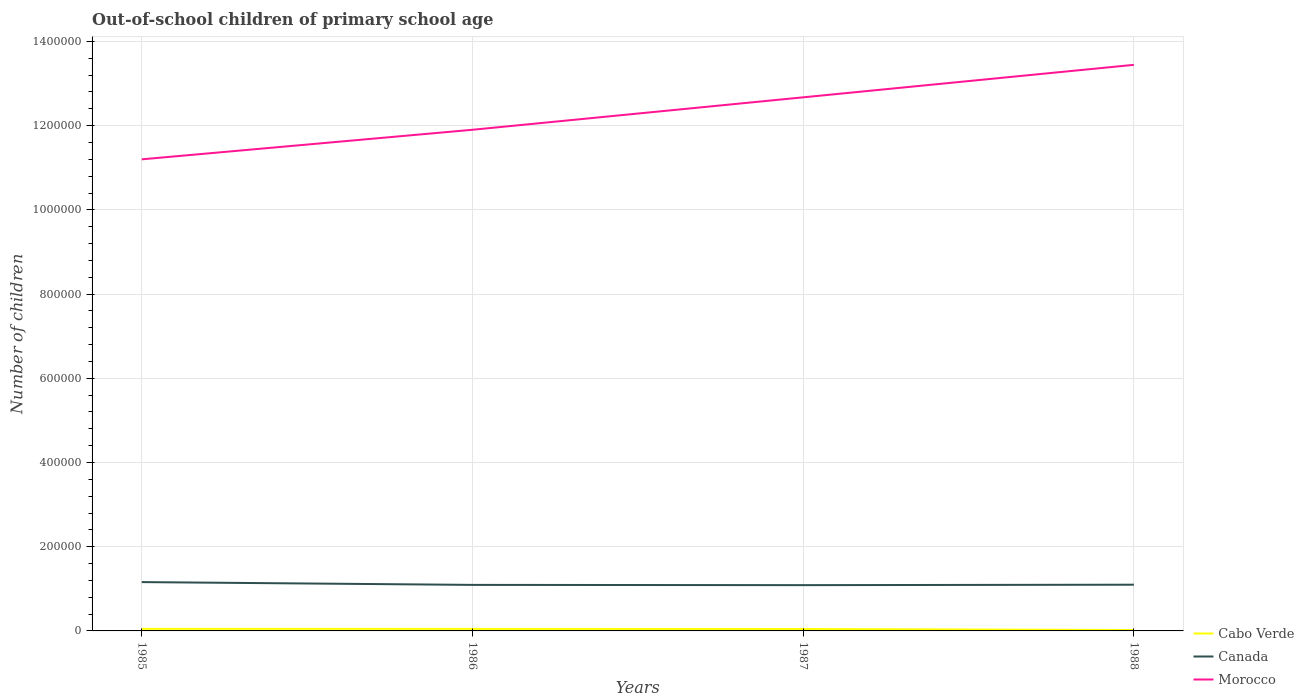Does the line corresponding to Cabo Verde intersect with the line corresponding to Morocco?
Your response must be concise. No. Is the number of lines equal to the number of legend labels?
Make the answer very short. Yes. Across all years, what is the maximum number of out-of-school children in Canada?
Provide a succinct answer. 1.09e+05. What is the total number of out-of-school children in Canada in the graph?
Provide a short and direct response. 7207. What is the difference between the highest and the second highest number of out-of-school children in Morocco?
Provide a succinct answer. 2.24e+05. Does the graph contain grids?
Your answer should be compact. Yes. Where does the legend appear in the graph?
Provide a short and direct response. Bottom right. What is the title of the graph?
Your answer should be very brief. Out-of-school children of primary school age. What is the label or title of the Y-axis?
Provide a succinct answer. Number of children. What is the Number of children of Cabo Verde in 1985?
Ensure brevity in your answer.  4877. What is the Number of children of Canada in 1985?
Keep it short and to the point. 1.16e+05. What is the Number of children in Morocco in 1985?
Provide a succinct answer. 1.12e+06. What is the Number of children in Cabo Verde in 1986?
Keep it short and to the point. 4765. What is the Number of children in Canada in 1986?
Offer a very short reply. 1.09e+05. What is the Number of children of Morocco in 1986?
Make the answer very short. 1.19e+06. What is the Number of children in Cabo Verde in 1987?
Provide a succinct answer. 4602. What is the Number of children in Canada in 1987?
Make the answer very short. 1.09e+05. What is the Number of children of Morocco in 1987?
Your response must be concise. 1.27e+06. What is the Number of children of Cabo Verde in 1988?
Your response must be concise. 2121. What is the Number of children of Canada in 1988?
Make the answer very short. 1.10e+05. What is the Number of children of Morocco in 1988?
Your response must be concise. 1.34e+06. Across all years, what is the maximum Number of children in Cabo Verde?
Make the answer very short. 4877. Across all years, what is the maximum Number of children of Canada?
Provide a short and direct response. 1.16e+05. Across all years, what is the maximum Number of children of Morocco?
Your response must be concise. 1.34e+06. Across all years, what is the minimum Number of children in Cabo Verde?
Your answer should be compact. 2121. Across all years, what is the minimum Number of children of Canada?
Offer a very short reply. 1.09e+05. Across all years, what is the minimum Number of children in Morocco?
Ensure brevity in your answer.  1.12e+06. What is the total Number of children in Cabo Verde in the graph?
Provide a succinct answer. 1.64e+04. What is the total Number of children in Canada in the graph?
Keep it short and to the point. 4.44e+05. What is the total Number of children in Morocco in the graph?
Provide a short and direct response. 4.92e+06. What is the difference between the Number of children in Cabo Verde in 1985 and that in 1986?
Provide a short and direct response. 112. What is the difference between the Number of children of Canada in 1985 and that in 1986?
Offer a very short reply. 6615. What is the difference between the Number of children of Morocco in 1985 and that in 1986?
Provide a short and direct response. -7.02e+04. What is the difference between the Number of children in Cabo Verde in 1985 and that in 1987?
Your response must be concise. 275. What is the difference between the Number of children of Canada in 1985 and that in 1987?
Your answer should be compact. 7207. What is the difference between the Number of children in Morocco in 1985 and that in 1987?
Offer a terse response. -1.47e+05. What is the difference between the Number of children of Cabo Verde in 1985 and that in 1988?
Keep it short and to the point. 2756. What is the difference between the Number of children in Canada in 1985 and that in 1988?
Your response must be concise. 6168. What is the difference between the Number of children in Morocco in 1985 and that in 1988?
Give a very brief answer. -2.24e+05. What is the difference between the Number of children of Cabo Verde in 1986 and that in 1987?
Offer a terse response. 163. What is the difference between the Number of children of Canada in 1986 and that in 1987?
Your response must be concise. 592. What is the difference between the Number of children of Morocco in 1986 and that in 1987?
Your answer should be very brief. -7.71e+04. What is the difference between the Number of children in Cabo Verde in 1986 and that in 1988?
Ensure brevity in your answer.  2644. What is the difference between the Number of children of Canada in 1986 and that in 1988?
Make the answer very short. -447. What is the difference between the Number of children in Morocco in 1986 and that in 1988?
Your answer should be very brief. -1.54e+05. What is the difference between the Number of children in Cabo Verde in 1987 and that in 1988?
Ensure brevity in your answer.  2481. What is the difference between the Number of children in Canada in 1987 and that in 1988?
Offer a very short reply. -1039. What is the difference between the Number of children in Morocco in 1987 and that in 1988?
Offer a terse response. -7.72e+04. What is the difference between the Number of children in Cabo Verde in 1985 and the Number of children in Canada in 1986?
Offer a very short reply. -1.04e+05. What is the difference between the Number of children in Cabo Verde in 1985 and the Number of children in Morocco in 1986?
Provide a succinct answer. -1.19e+06. What is the difference between the Number of children of Canada in 1985 and the Number of children of Morocco in 1986?
Give a very brief answer. -1.07e+06. What is the difference between the Number of children in Cabo Verde in 1985 and the Number of children in Canada in 1987?
Your answer should be very brief. -1.04e+05. What is the difference between the Number of children of Cabo Verde in 1985 and the Number of children of Morocco in 1987?
Offer a terse response. -1.26e+06. What is the difference between the Number of children in Canada in 1985 and the Number of children in Morocco in 1987?
Give a very brief answer. -1.15e+06. What is the difference between the Number of children of Cabo Verde in 1985 and the Number of children of Canada in 1988?
Provide a succinct answer. -1.05e+05. What is the difference between the Number of children of Cabo Verde in 1985 and the Number of children of Morocco in 1988?
Make the answer very short. -1.34e+06. What is the difference between the Number of children in Canada in 1985 and the Number of children in Morocco in 1988?
Your answer should be compact. -1.23e+06. What is the difference between the Number of children in Cabo Verde in 1986 and the Number of children in Canada in 1987?
Offer a very short reply. -1.04e+05. What is the difference between the Number of children in Cabo Verde in 1986 and the Number of children in Morocco in 1987?
Provide a short and direct response. -1.26e+06. What is the difference between the Number of children of Canada in 1986 and the Number of children of Morocco in 1987?
Ensure brevity in your answer.  -1.16e+06. What is the difference between the Number of children of Cabo Verde in 1986 and the Number of children of Canada in 1988?
Give a very brief answer. -1.05e+05. What is the difference between the Number of children of Cabo Verde in 1986 and the Number of children of Morocco in 1988?
Offer a very short reply. -1.34e+06. What is the difference between the Number of children of Canada in 1986 and the Number of children of Morocco in 1988?
Your answer should be compact. -1.24e+06. What is the difference between the Number of children of Cabo Verde in 1987 and the Number of children of Canada in 1988?
Ensure brevity in your answer.  -1.05e+05. What is the difference between the Number of children of Cabo Verde in 1987 and the Number of children of Morocco in 1988?
Offer a terse response. -1.34e+06. What is the difference between the Number of children in Canada in 1987 and the Number of children in Morocco in 1988?
Keep it short and to the point. -1.24e+06. What is the average Number of children of Cabo Verde per year?
Keep it short and to the point. 4091.25. What is the average Number of children in Canada per year?
Your response must be concise. 1.11e+05. What is the average Number of children of Morocco per year?
Give a very brief answer. 1.23e+06. In the year 1985, what is the difference between the Number of children of Cabo Verde and Number of children of Canada?
Provide a succinct answer. -1.11e+05. In the year 1985, what is the difference between the Number of children of Cabo Verde and Number of children of Morocco?
Your answer should be compact. -1.12e+06. In the year 1985, what is the difference between the Number of children of Canada and Number of children of Morocco?
Your answer should be compact. -1.00e+06. In the year 1986, what is the difference between the Number of children in Cabo Verde and Number of children in Canada?
Provide a short and direct response. -1.05e+05. In the year 1986, what is the difference between the Number of children in Cabo Verde and Number of children in Morocco?
Your answer should be very brief. -1.19e+06. In the year 1986, what is the difference between the Number of children in Canada and Number of children in Morocco?
Your answer should be compact. -1.08e+06. In the year 1987, what is the difference between the Number of children of Cabo Verde and Number of children of Canada?
Provide a short and direct response. -1.04e+05. In the year 1987, what is the difference between the Number of children of Cabo Verde and Number of children of Morocco?
Your answer should be very brief. -1.26e+06. In the year 1987, what is the difference between the Number of children of Canada and Number of children of Morocco?
Ensure brevity in your answer.  -1.16e+06. In the year 1988, what is the difference between the Number of children in Cabo Verde and Number of children in Canada?
Ensure brevity in your answer.  -1.08e+05. In the year 1988, what is the difference between the Number of children in Cabo Verde and Number of children in Morocco?
Keep it short and to the point. -1.34e+06. In the year 1988, what is the difference between the Number of children in Canada and Number of children in Morocco?
Make the answer very short. -1.23e+06. What is the ratio of the Number of children in Cabo Verde in 1985 to that in 1986?
Provide a short and direct response. 1.02. What is the ratio of the Number of children of Canada in 1985 to that in 1986?
Offer a terse response. 1.06. What is the ratio of the Number of children of Morocco in 1985 to that in 1986?
Provide a succinct answer. 0.94. What is the ratio of the Number of children in Cabo Verde in 1985 to that in 1987?
Make the answer very short. 1.06. What is the ratio of the Number of children in Canada in 1985 to that in 1987?
Offer a terse response. 1.07. What is the ratio of the Number of children in Morocco in 1985 to that in 1987?
Offer a terse response. 0.88. What is the ratio of the Number of children in Cabo Verde in 1985 to that in 1988?
Your answer should be very brief. 2.3. What is the ratio of the Number of children of Canada in 1985 to that in 1988?
Keep it short and to the point. 1.06. What is the ratio of the Number of children of Morocco in 1985 to that in 1988?
Give a very brief answer. 0.83. What is the ratio of the Number of children of Cabo Verde in 1986 to that in 1987?
Provide a succinct answer. 1.04. What is the ratio of the Number of children in Canada in 1986 to that in 1987?
Your response must be concise. 1.01. What is the ratio of the Number of children in Morocco in 1986 to that in 1987?
Make the answer very short. 0.94. What is the ratio of the Number of children of Cabo Verde in 1986 to that in 1988?
Make the answer very short. 2.25. What is the ratio of the Number of children of Canada in 1986 to that in 1988?
Offer a very short reply. 1. What is the ratio of the Number of children in Morocco in 1986 to that in 1988?
Offer a terse response. 0.89. What is the ratio of the Number of children of Cabo Verde in 1987 to that in 1988?
Your answer should be compact. 2.17. What is the ratio of the Number of children in Canada in 1987 to that in 1988?
Your answer should be very brief. 0.99. What is the ratio of the Number of children of Morocco in 1987 to that in 1988?
Offer a terse response. 0.94. What is the difference between the highest and the second highest Number of children of Cabo Verde?
Give a very brief answer. 112. What is the difference between the highest and the second highest Number of children of Canada?
Your response must be concise. 6168. What is the difference between the highest and the second highest Number of children of Morocco?
Ensure brevity in your answer.  7.72e+04. What is the difference between the highest and the lowest Number of children of Cabo Verde?
Ensure brevity in your answer.  2756. What is the difference between the highest and the lowest Number of children of Canada?
Keep it short and to the point. 7207. What is the difference between the highest and the lowest Number of children of Morocco?
Give a very brief answer. 2.24e+05. 